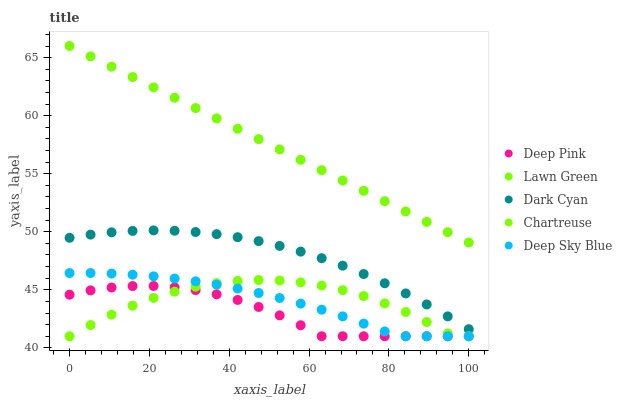Does Deep Pink have the minimum area under the curve?
Answer yes or no. Yes. Does Lawn Green have the maximum area under the curve?
Answer yes or no. Yes. Does Chartreuse have the minimum area under the curve?
Answer yes or no. No. Does Chartreuse have the maximum area under the curve?
Answer yes or no. No. Is Lawn Green the smoothest?
Answer yes or no. Yes. Is Chartreuse the roughest?
Answer yes or no. Yes. Is Chartreuse the smoothest?
Answer yes or no. No. Is Lawn Green the roughest?
Answer yes or no. No. Does Chartreuse have the lowest value?
Answer yes or no. Yes. Does Lawn Green have the lowest value?
Answer yes or no. No. Does Lawn Green have the highest value?
Answer yes or no. Yes. Does Chartreuse have the highest value?
Answer yes or no. No. Is Chartreuse less than Lawn Green?
Answer yes or no. Yes. Is Lawn Green greater than Dark Cyan?
Answer yes or no. Yes. Does Deep Pink intersect Deep Sky Blue?
Answer yes or no. Yes. Is Deep Pink less than Deep Sky Blue?
Answer yes or no. No. Is Deep Pink greater than Deep Sky Blue?
Answer yes or no. No. Does Chartreuse intersect Lawn Green?
Answer yes or no. No. 